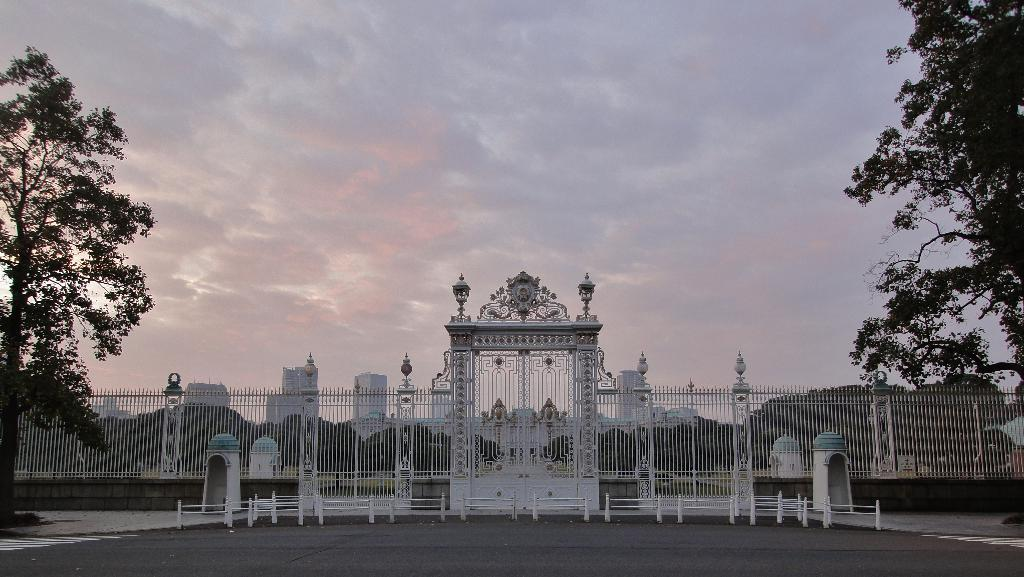What type of structure can be seen in the image? There are iron grilles and a gate in the image. What is visible behind the gate? Trees and buildings are visible behind the gate. What is the condition of the sky in the image? The sky is visible in the image. What objects are in front of the gate? Small poles are in front of the gate. What is the ground surface in front of the gate? There is a road in front of the gate. What type of watch is being worn by the crate in the image? There is no watch or crate present in the image. 